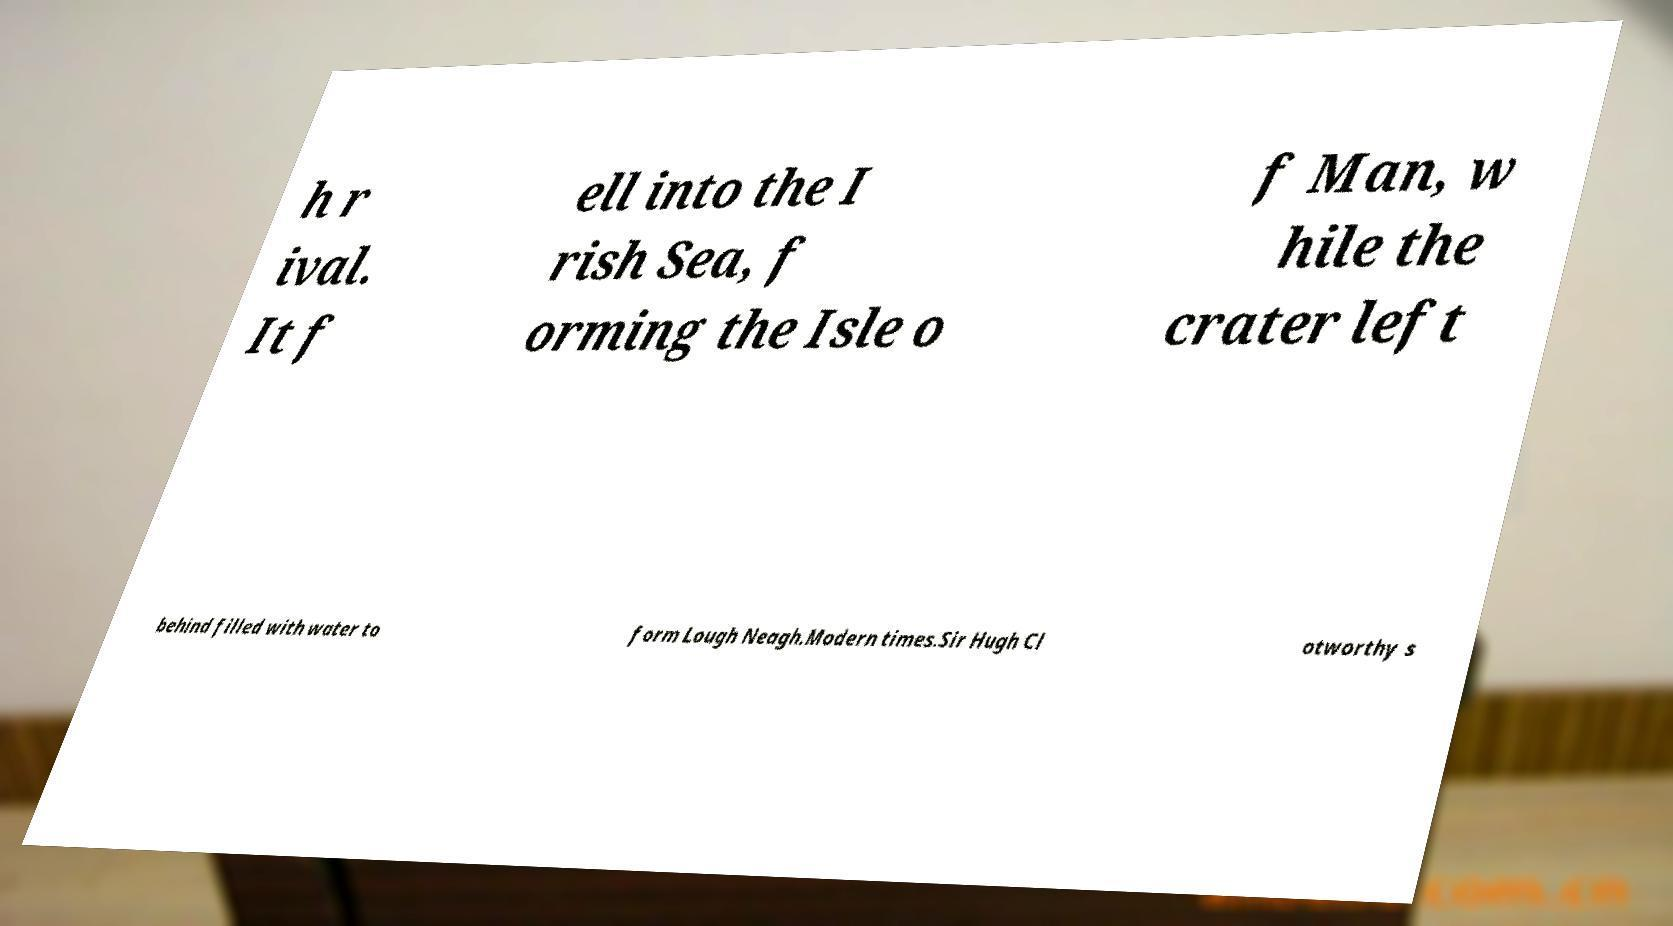Please identify and transcribe the text found in this image. h r ival. It f ell into the I rish Sea, f orming the Isle o f Man, w hile the crater left behind filled with water to form Lough Neagh.Modern times.Sir Hugh Cl otworthy s 